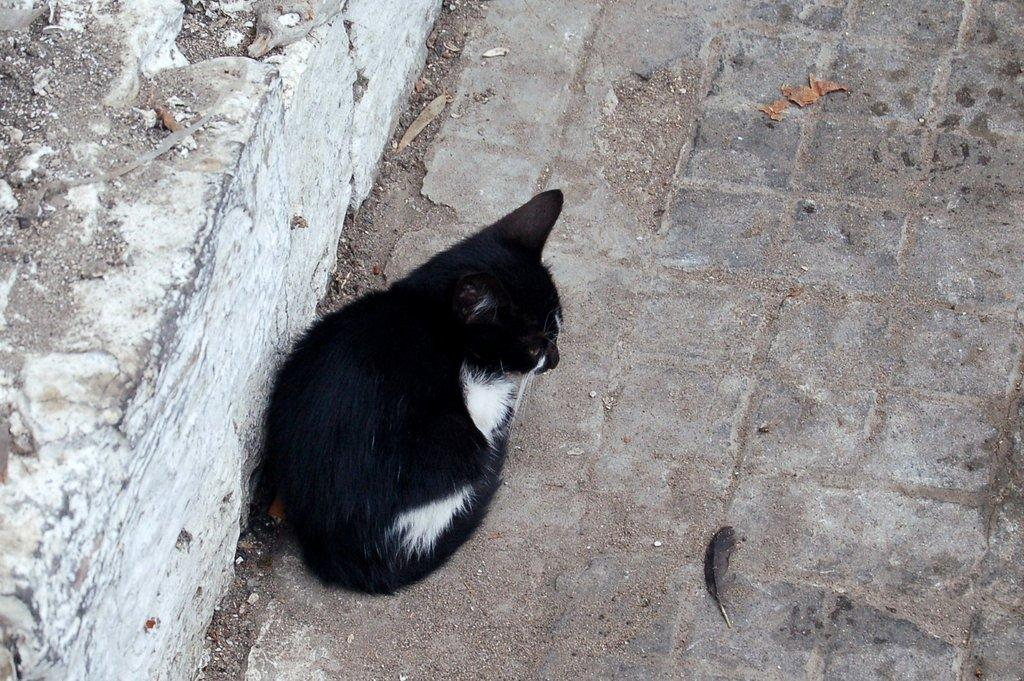What type of animal is in the image? There is a black color cat in the image. What is the cat doing in the image? The cat is sitting on the ground. What can be seen on the left side of the image? There is a white color wall on the left side of the image. What type of beast is performing a show in the image? There is no beast performing a show in the image; it features a black color cat sitting on the ground. How far does the cat stretch in the image? The cat is sitting on the ground, so it is not stretching in the image. 